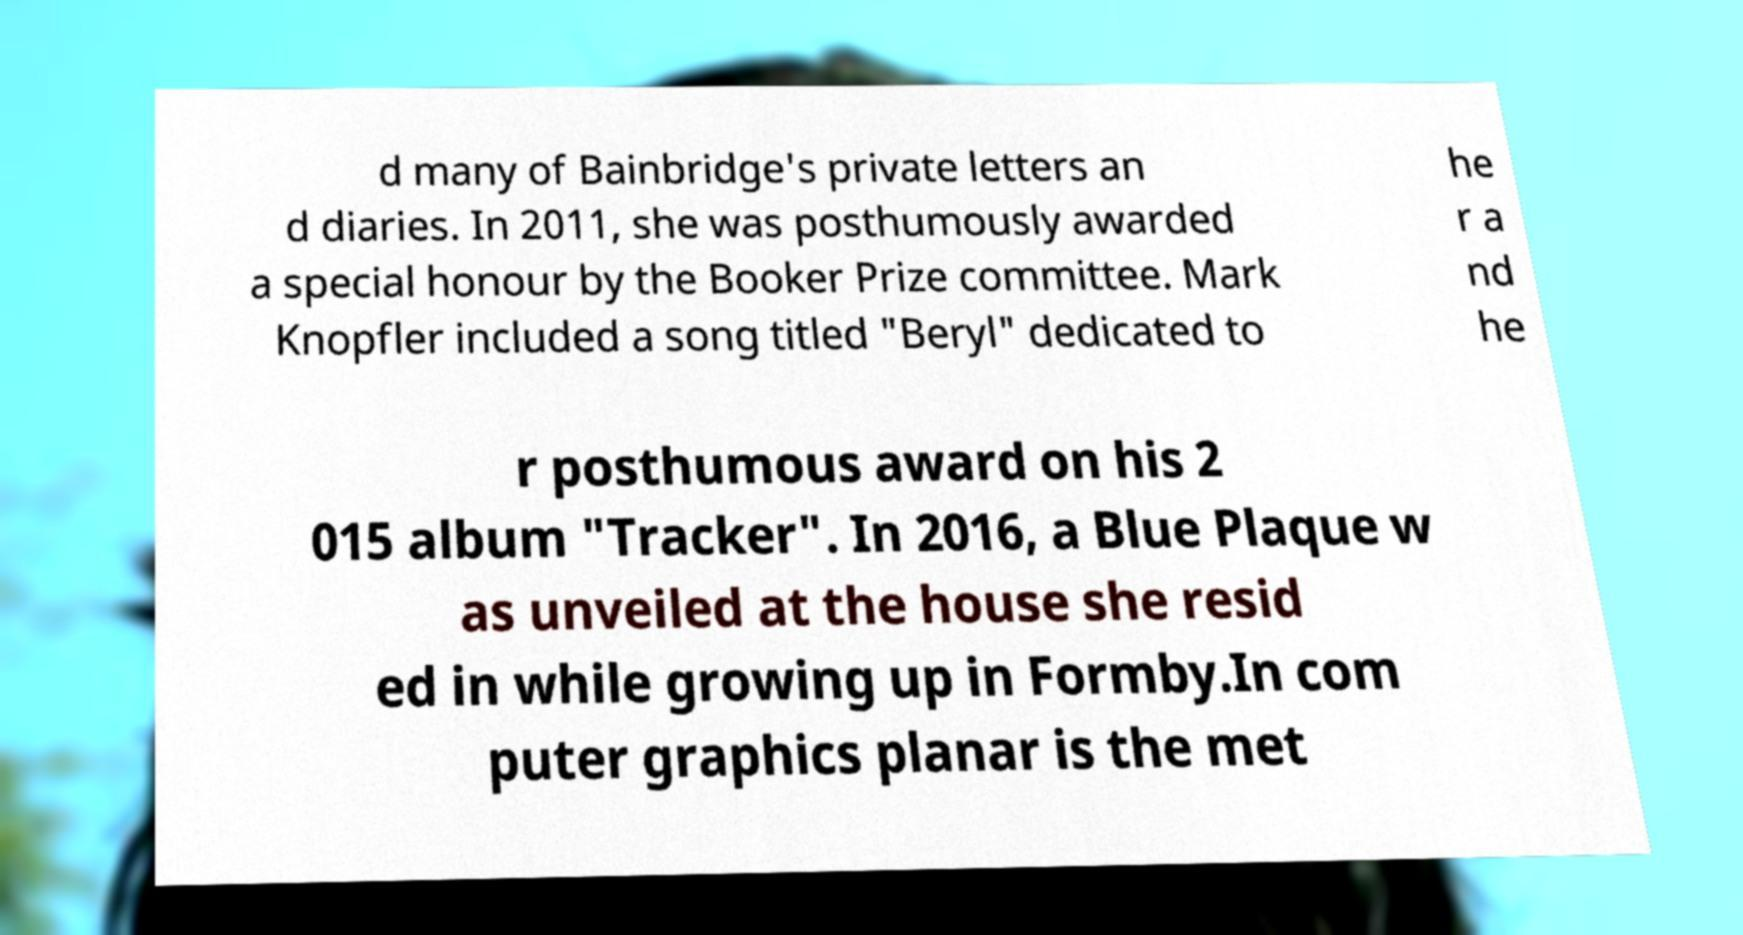Could you extract and type out the text from this image? d many of Bainbridge's private letters an d diaries. In 2011, she was posthumously awarded a special honour by the Booker Prize committee. Mark Knopfler included a song titled "Beryl" dedicated to he r a nd he r posthumous award on his 2 015 album "Tracker". In 2016, a Blue Plaque w as unveiled at the house she resid ed in while growing up in Formby.In com puter graphics planar is the met 